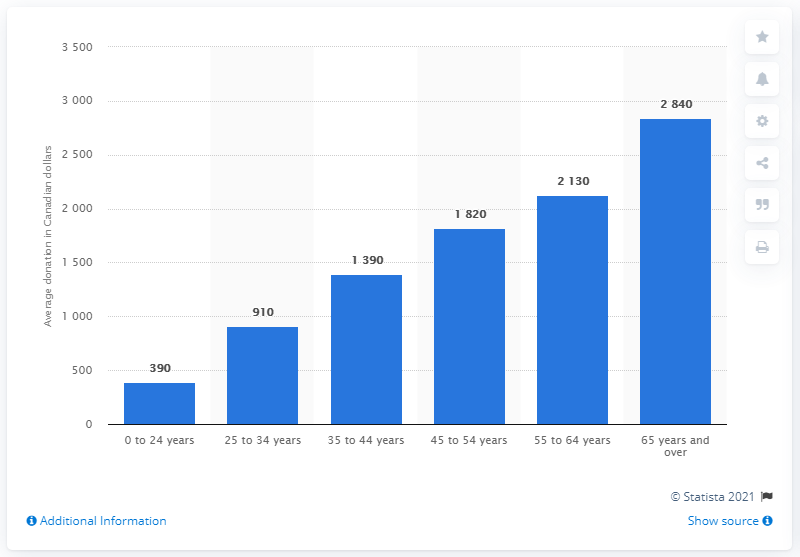Highlight a few significant elements in this photo. In 2019, the average donation made by 25 to 34 year olds in Canada was $910. The sum total of donors in the age group 0 to 24 and 25 to 34 years is 1,300. The age group that donated the highest dollar amount was 65 years and older. 